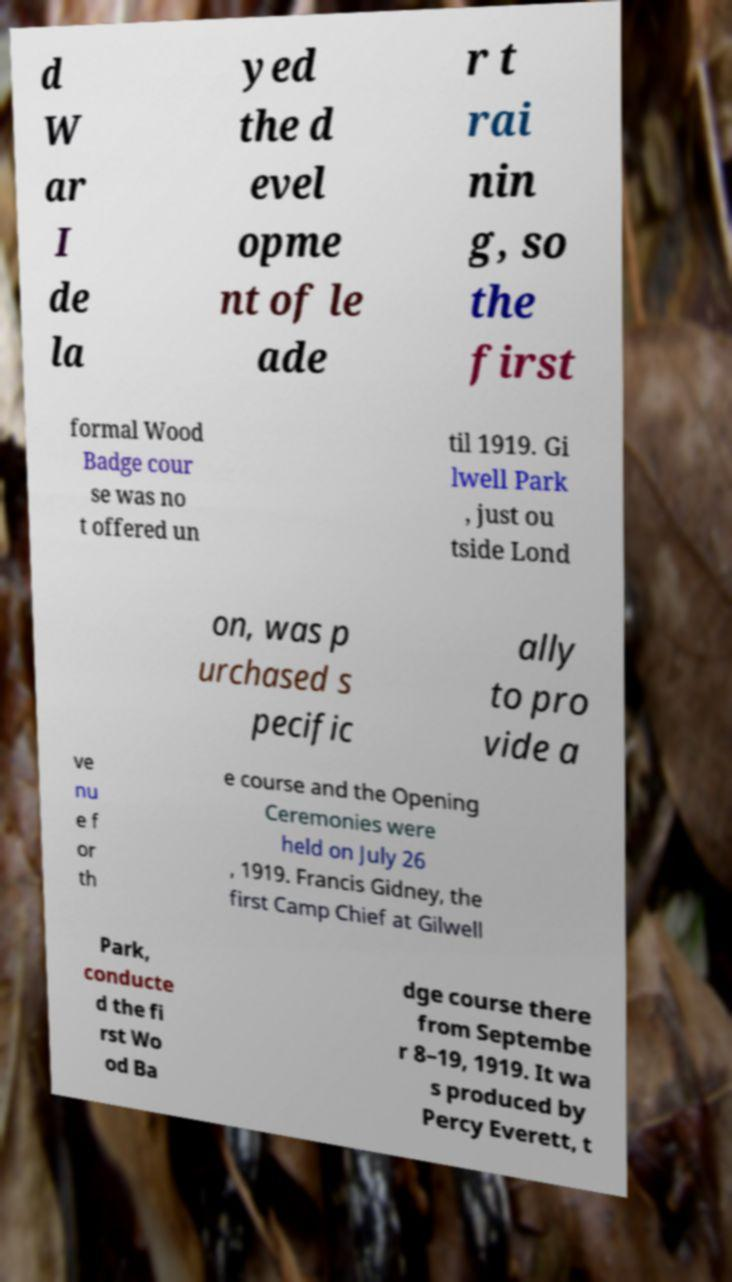Could you assist in decoding the text presented in this image and type it out clearly? d W ar I de la yed the d evel opme nt of le ade r t rai nin g, so the first formal Wood Badge cour se was no t offered un til 1919. Gi lwell Park , just ou tside Lond on, was p urchased s pecific ally to pro vide a ve nu e f or th e course and the Opening Ceremonies were held on July 26 , 1919. Francis Gidney, the first Camp Chief at Gilwell Park, conducte d the fi rst Wo od Ba dge course there from Septembe r 8–19, 1919. It wa s produced by Percy Everett, t 